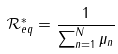<formula> <loc_0><loc_0><loc_500><loc_500>\mathcal { R } _ { e q } ^ { * } = \frac { 1 } { \sum _ { n = 1 } ^ { N } \mu _ { n } }</formula> 